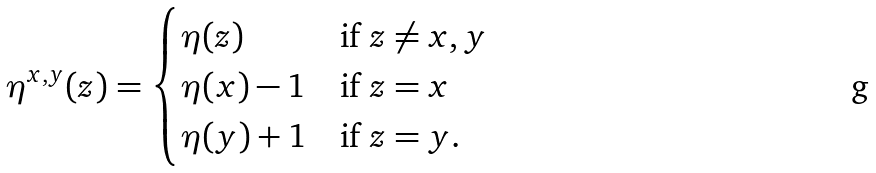<formula> <loc_0><loc_0><loc_500><loc_500>\eta ^ { x , y } ( z ) = \begin{cases} \eta ( z ) & \text {if $z \neq x,y$} \\ \eta ( x ) - 1 & \text {if $z = x$} \\ \eta ( y ) + 1 & \text {if $z = y$} . \end{cases}</formula> 